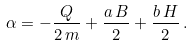<formula> <loc_0><loc_0><loc_500><loc_500>\alpha = - \frac { Q } { 2 \, m } + \frac { a \, B } { 2 } + \frac { b \, H } { 2 } \, .</formula> 